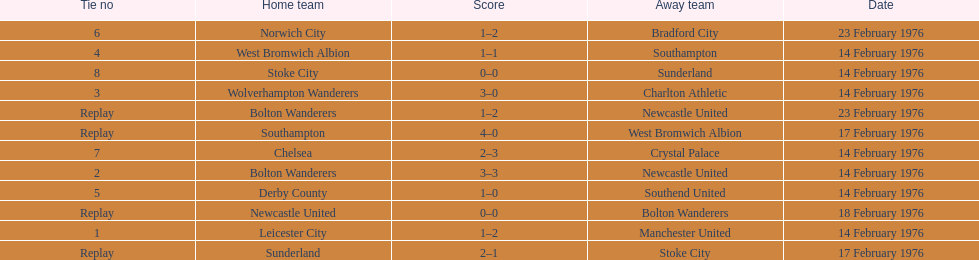How many of these games occurred before 17 february 1976? 7. 